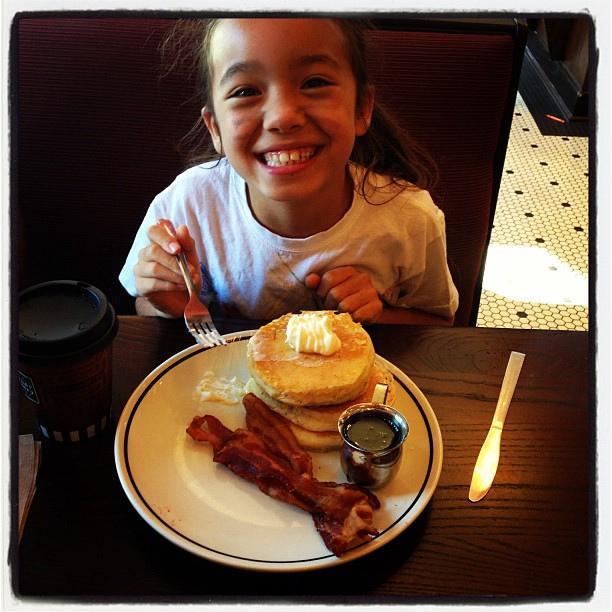How many cups are in the picture?
Give a very brief answer. 2. 